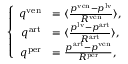Convert formula to latex. <formula><loc_0><loc_0><loc_500><loc_500>\left \{ \begin{array} { r l } { q ^ { v e n } } & { = \langle \frac { p ^ { v e n } - p ^ { l v } } { R ^ { v e n } } \rangle , } \\ { q ^ { a r t } } & { = \langle \frac { p ^ { l v } - p ^ { a r t } } { R ^ { a r t } } \rangle , } \\ { q ^ { p e r } } & { = \frac { p ^ { a r t } - p ^ { v e n } } { R ^ { p e r } } , } \end{array}</formula> 